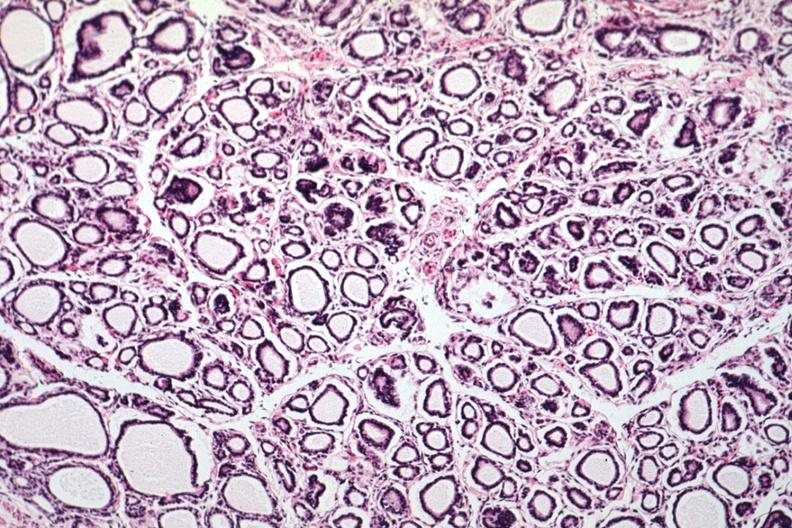where is this part in the figure?
Answer the question using a single word or phrase. Endocrine system 